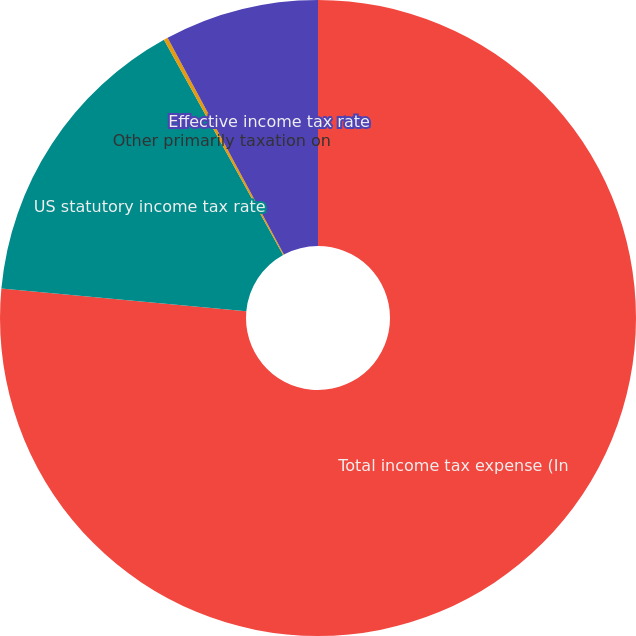<chart> <loc_0><loc_0><loc_500><loc_500><pie_chart><fcel>Total income tax expense (In<fcel>US statutory income tax rate<fcel>Other primarily taxation on<fcel>Effective income tax rate<nl><fcel>76.48%<fcel>15.47%<fcel>0.21%<fcel>7.84%<nl></chart> 